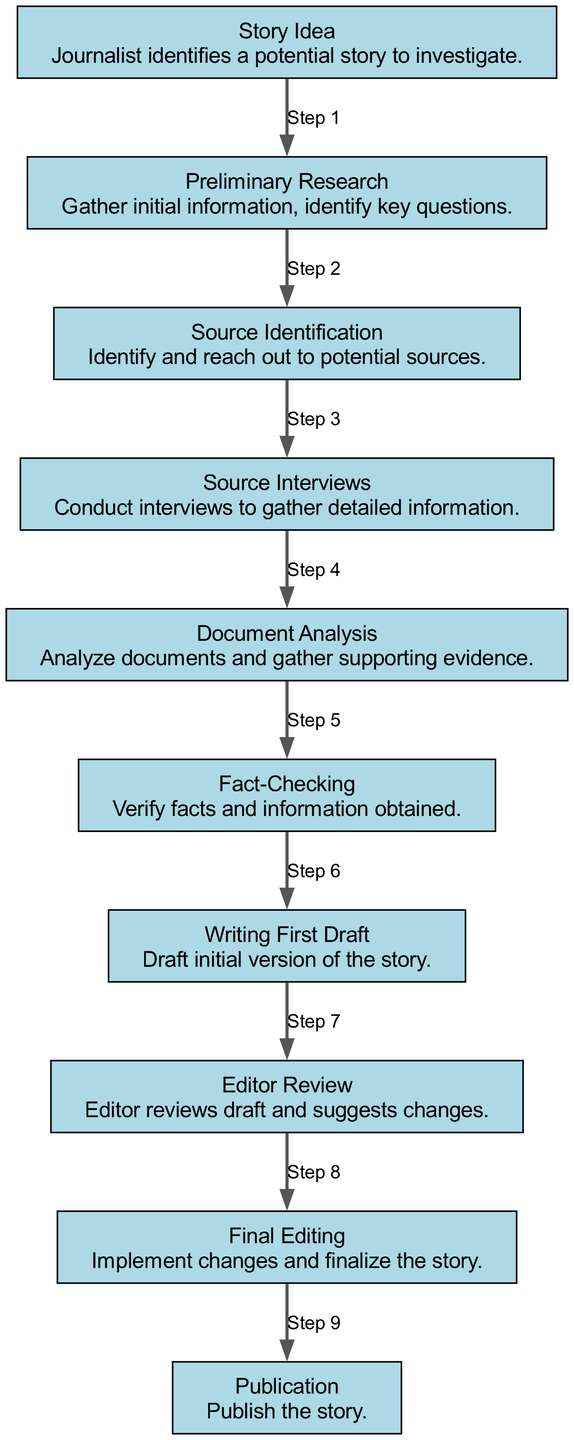What is the first step in the investigative journalism process? The diagram shows that the first node labeled "Story Idea" is at the top of the flowchart, indicating it is the starting point of the investigative process.
Answer: Story Idea How many nodes are present in the diagram? By counting the nodes listed in the data section, there are ten distinct steps in the investigative journalism process.
Answer: Ten What is the last step before publication? The edge leading to "Publication" directly follows the node labeled "Final Editing," indicating that final editing is the last process before publication.
Answer: Final Editing Which step involves interviewing sources? The diagram clearly shows that the node labeled "Source Interviews" handles the gathering of detailed information through interviews, positioned after "Source Identification."
Answer: Source Interviews What step comes after fact-checking? The order in the diagram shows that after "Fact-Checking," the next step is "Writing First Draft," as indicated by the directed edges between the nodes.
Answer: Writing First Draft Which two processes are directly connected by the edge labeled "Step 3"? The edge labeled "Step 3" connects the nodes "Source Identification" and "Source Interviews," indicating the progression from identifying sources to interviewing them.
Answer: Source Identification and Source Interviews What is the primary objective during document analysis? The "Document Analysis" node indicates the goal is to analyze documents and gather supporting evidence, reflecting the critical nature of this step in the process.
Answer: Analyze documents and gather supporting evidence How many steps are there from the initial story idea to publication? By following the edges from "Story Idea" to "Publication," each step connects sequentially, totaling nine steps to reach publication from the initial idea.
Answer: Nine What step occurs after the initial draft writing? The sequence indicates that "Editor Review" follows directly after "Writing First Draft," which emphasizes the editorial process after a draft is written.
Answer: Editor Review 